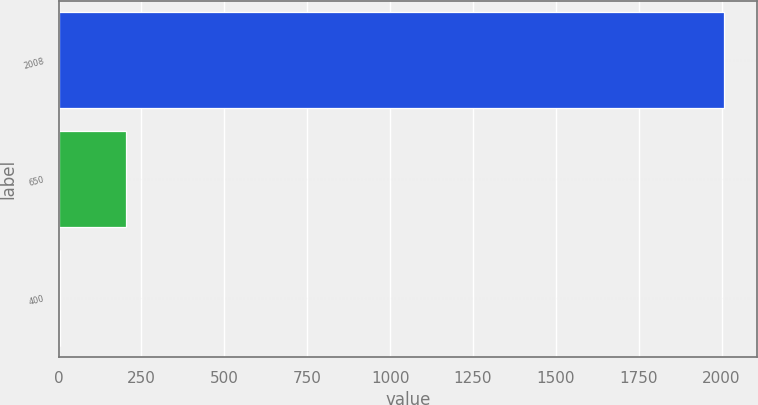Convert chart to OTSL. <chart><loc_0><loc_0><loc_500><loc_500><bar_chart><fcel>2008<fcel>650<fcel>400<nl><fcel>2007<fcel>204.3<fcel>4<nl></chart> 